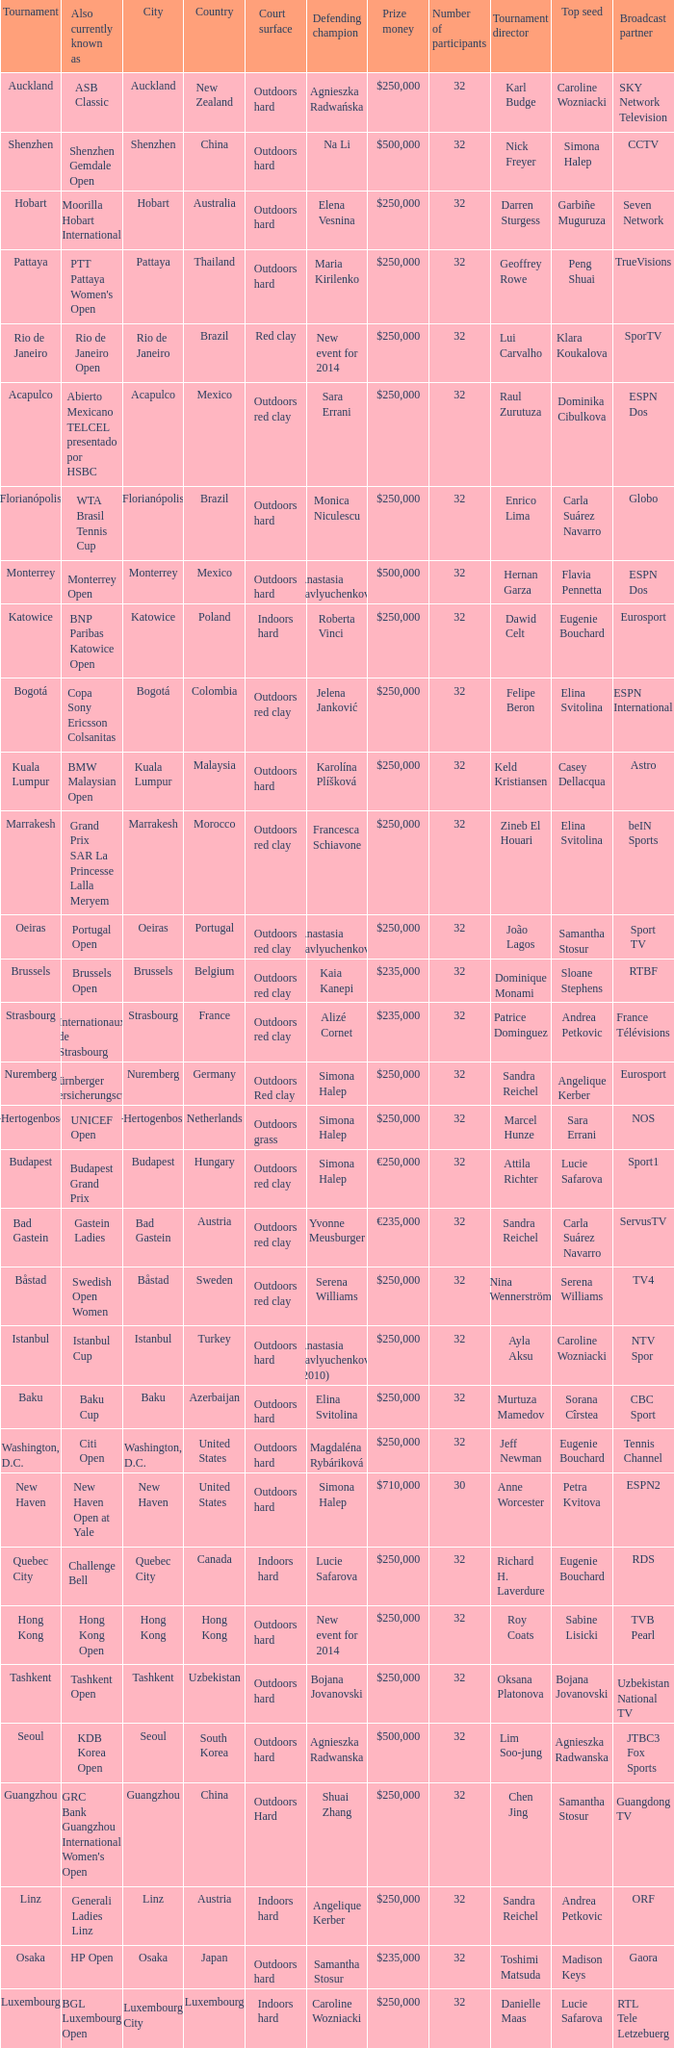How many defending champions from thailand? 1.0. 